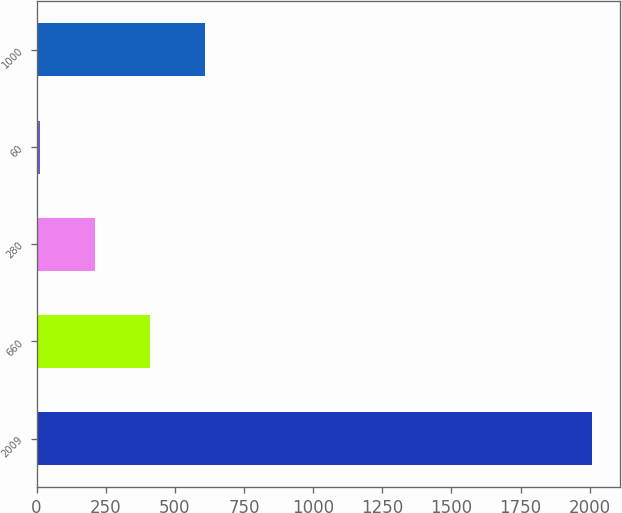<chart> <loc_0><loc_0><loc_500><loc_500><bar_chart><fcel>2009<fcel>660<fcel>280<fcel>60<fcel>1000<nl><fcel>2008<fcel>410.4<fcel>210.7<fcel>11<fcel>610.1<nl></chart> 